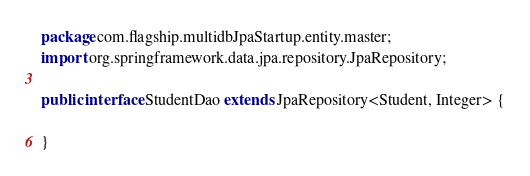<code> <loc_0><loc_0><loc_500><loc_500><_Java_>package com.flagship.multidbJpaStartup.entity.master;
import org.springframework.data.jpa.repository.JpaRepository;

public interface StudentDao extends JpaRepository<Student, Integer> {

}
</code> 